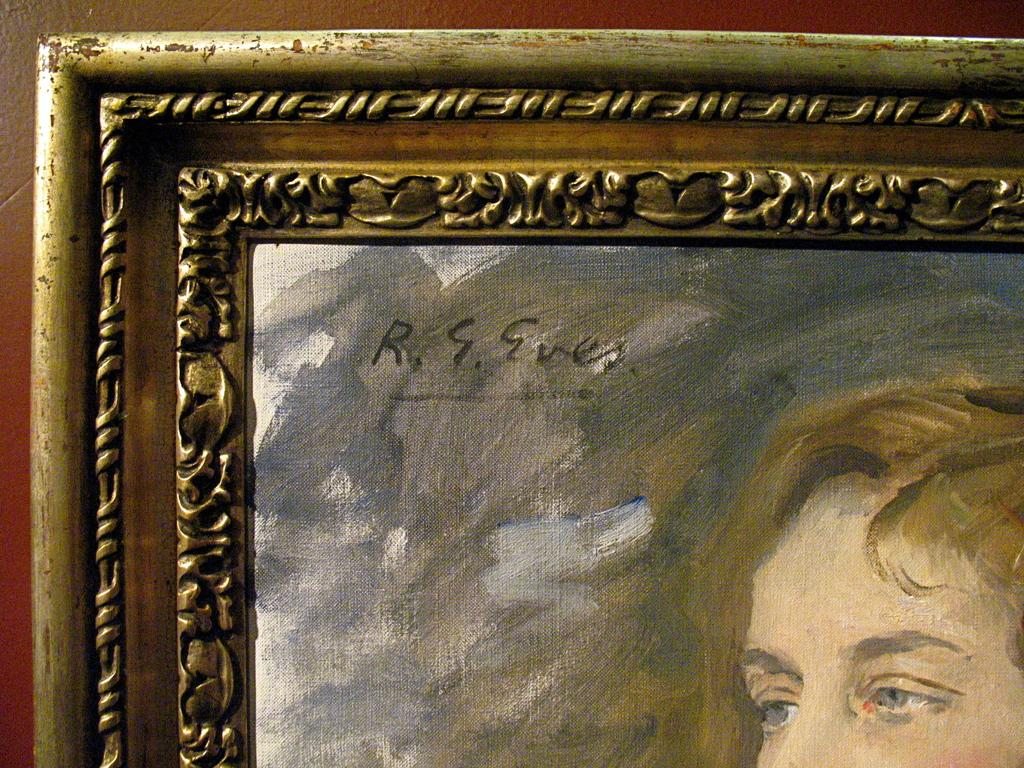What is the main subject of the image? There is a painting in the image. What does the painting depict? The painting depicts a person. How is the painting displayed in the image? The painting is in a frame. Can you tell me how many connections are visible in the painting? There are no connections visible in the painting, as it is a depiction of a person and not a network or system. 